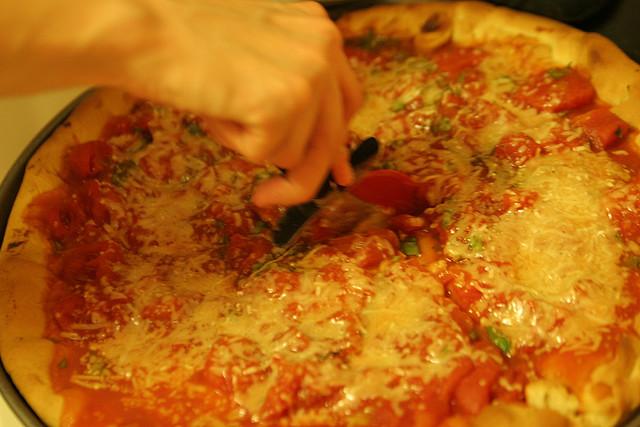What type of meat is pictured?
Be succinct. Pepperoni. What topping does the pizza have?
Be succinct. Cheese. What size is the pizza?
Quick response, please. Large. Is this a high class dish?
Short answer required. No. What is being used to cut the pizza?
Be succinct. Pizza cutter. Is the picture of a Sicilian pizza or a deep dish pizza?
Short answer required. Sicilian. Has the food been eaten?
Keep it brief. No. What type of crust is this?
Concise answer only. Thin. Is this a pizza?
Short answer required. Yes. How many people are in this photo?
Answer briefly. 1. 